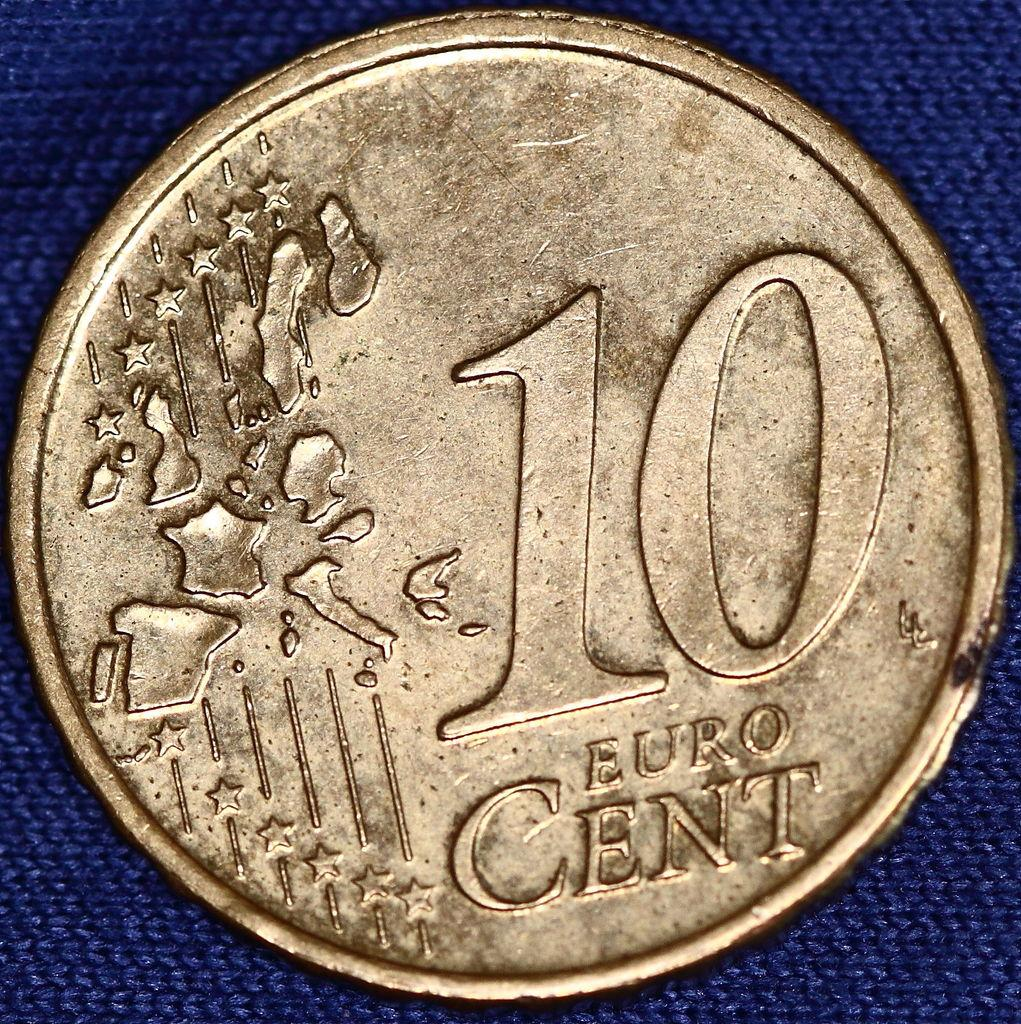<image>
Create a compact narrative representing the image presented. Gold coin showing 10 Euro cent on top of a blue surface. 